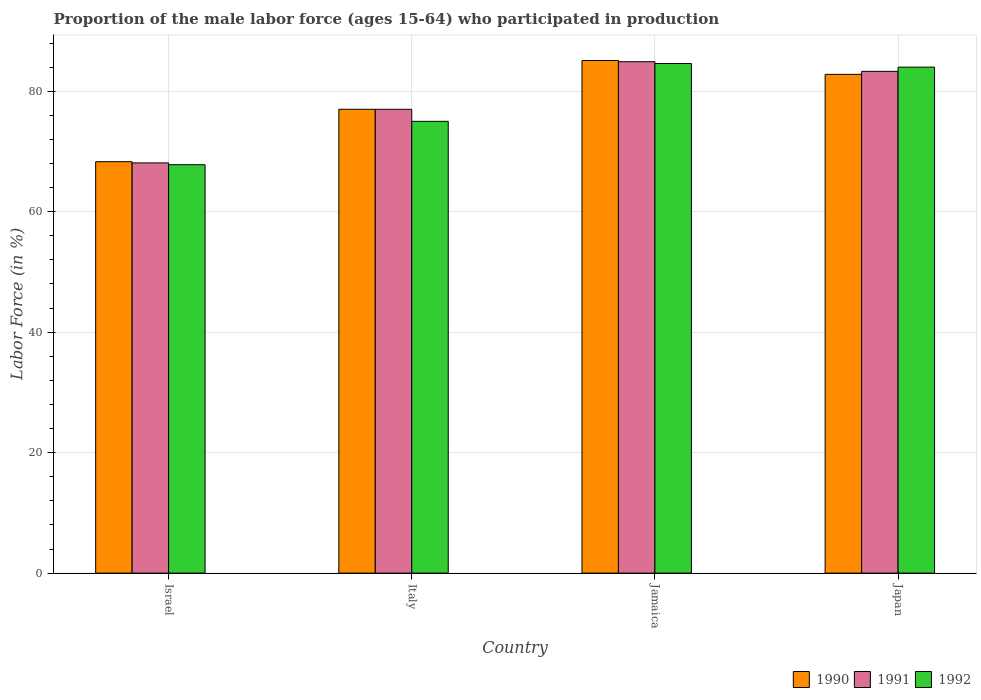How many groups of bars are there?
Provide a succinct answer. 4. Are the number of bars per tick equal to the number of legend labels?
Give a very brief answer. Yes. How many bars are there on the 4th tick from the left?
Keep it short and to the point. 3. How many bars are there on the 4th tick from the right?
Make the answer very short. 3. In how many cases, is the number of bars for a given country not equal to the number of legend labels?
Offer a very short reply. 0. Across all countries, what is the maximum proportion of the male labor force who participated in production in 1992?
Make the answer very short. 84.6. Across all countries, what is the minimum proportion of the male labor force who participated in production in 1992?
Provide a succinct answer. 67.8. In which country was the proportion of the male labor force who participated in production in 1991 maximum?
Provide a succinct answer. Jamaica. In which country was the proportion of the male labor force who participated in production in 1992 minimum?
Give a very brief answer. Israel. What is the total proportion of the male labor force who participated in production in 1991 in the graph?
Your answer should be very brief. 313.3. What is the difference between the proportion of the male labor force who participated in production in 1991 in Jamaica and that in Japan?
Your response must be concise. 1.6. What is the difference between the proportion of the male labor force who participated in production in 1992 in Jamaica and the proportion of the male labor force who participated in production in 1990 in Japan?
Offer a very short reply. 1.8. What is the average proportion of the male labor force who participated in production in 1990 per country?
Provide a short and direct response. 78.3. What is the ratio of the proportion of the male labor force who participated in production in 1991 in Italy to that in Jamaica?
Your answer should be very brief. 0.91. What is the difference between the highest and the second highest proportion of the male labor force who participated in production in 1991?
Give a very brief answer. -1.6. What is the difference between the highest and the lowest proportion of the male labor force who participated in production in 1991?
Offer a terse response. 16.8. Is the sum of the proportion of the male labor force who participated in production in 1990 in Israel and Italy greater than the maximum proportion of the male labor force who participated in production in 1991 across all countries?
Offer a terse response. Yes. What does the 3rd bar from the left in Japan represents?
Ensure brevity in your answer.  1992. What does the 1st bar from the right in Japan represents?
Ensure brevity in your answer.  1992. Is it the case that in every country, the sum of the proportion of the male labor force who participated in production in 1991 and proportion of the male labor force who participated in production in 1990 is greater than the proportion of the male labor force who participated in production in 1992?
Your answer should be compact. Yes. What is the title of the graph?
Offer a very short reply. Proportion of the male labor force (ages 15-64) who participated in production. What is the label or title of the X-axis?
Give a very brief answer. Country. What is the label or title of the Y-axis?
Offer a very short reply. Labor Force (in %). What is the Labor Force (in %) of 1990 in Israel?
Your response must be concise. 68.3. What is the Labor Force (in %) of 1991 in Israel?
Make the answer very short. 68.1. What is the Labor Force (in %) of 1992 in Israel?
Keep it short and to the point. 67.8. What is the Labor Force (in %) of 1990 in Italy?
Your response must be concise. 77. What is the Labor Force (in %) of 1991 in Italy?
Make the answer very short. 77. What is the Labor Force (in %) in 1990 in Jamaica?
Make the answer very short. 85.1. What is the Labor Force (in %) of 1991 in Jamaica?
Keep it short and to the point. 84.9. What is the Labor Force (in %) of 1992 in Jamaica?
Offer a terse response. 84.6. What is the Labor Force (in %) of 1990 in Japan?
Ensure brevity in your answer.  82.8. What is the Labor Force (in %) of 1991 in Japan?
Provide a succinct answer. 83.3. Across all countries, what is the maximum Labor Force (in %) of 1990?
Your response must be concise. 85.1. Across all countries, what is the maximum Labor Force (in %) of 1991?
Your answer should be compact. 84.9. Across all countries, what is the maximum Labor Force (in %) of 1992?
Provide a succinct answer. 84.6. Across all countries, what is the minimum Labor Force (in %) of 1990?
Ensure brevity in your answer.  68.3. Across all countries, what is the minimum Labor Force (in %) of 1991?
Offer a very short reply. 68.1. Across all countries, what is the minimum Labor Force (in %) in 1992?
Your answer should be compact. 67.8. What is the total Labor Force (in %) in 1990 in the graph?
Offer a terse response. 313.2. What is the total Labor Force (in %) in 1991 in the graph?
Keep it short and to the point. 313.3. What is the total Labor Force (in %) of 1992 in the graph?
Give a very brief answer. 311.4. What is the difference between the Labor Force (in %) in 1992 in Israel and that in Italy?
Keep it short and to the point. -7.2. What is the difference between the Labor Force (in %) in 1990 in Israel and that in Jamaica?
Your response must be concise. -16.8. What is the difference between the Labor Force (in %) of 1991 in Israel and that in Jamaica?
Provide a short and direct response. -16.8. What is the difference between the Labor Force (in %) of 1992 in Israel and that in Jamaica?
Make the answer very short. -16.8. What is the difference between the Labor Force (in %) of 1990 in Israel and that in Japan?
Keep it short and to the point. -14.5. What is the difference between the Labor Force (in %) in 1991 in Israel and that in Japan?
Give a very brief answer. -15.2. What is the difference between the Labor Force (in %) in 1992 in Israel and that in Japan?
Make the answer very short. -16.2. What is the difference between the Labor Force (in %) of 1991 in Italy and that in Jamaica?
Provide a short and direct response. -7.9. What is the difference between the Labor Force (in %) of 1992 in Italy and that in Jamaica?
Keep it short and to the point. -9.6. What is the difference between the Labor Force (in %) of 1990 in Italy and that in Japan?
Your answer should be very brief. -5.8. What is the difference between the Labor Force (in %) of 1991 in Jamaica and that in Japan?
Offer a very short reply. 1.6. What is the difference between the Labor Force (in %) of 1990 in Israel and the Labor Force (in %) of 1991 in Italy?
Your response must be concise. -8.7. What is the difference between the Labor Force (in %) in 1991 in Israel and the Labor Force (in %) in 1992 in Italy?
Your answer should be very brief. -6.9. What is the difference between the Labor Force (in %) of 1990 in Israel and the Labor Force (in %) of 1991 in Jamaica?
Make the answer very short. -16.6. What is the difference between the Labor Force (in %) in 1990 in Israel and the Labor Force (in %) in 1992 in Jamaica?
Offer a very short reply. -16.3. What is the difference between the Labor Force (in %) in 1991 in Israel and the Labor Force (in %) in 1992 in Jamaica?
Your response must be concise. -16.5. What is the difference between the Labor Force (in %) in 1990 in Israel and the Labor Force (in %) in 1992 in Japan?
Offer a very short reply. -15.7. What is the difference between the Labor Force (in %) in 1991 in Israel and the Labor Force (in %) in 1992 in Japan?
Make the answer very short. -15.9. What is the difference between the Labor Force (in %) of 1991 in Italy and the Labor Force (in %) of 1992 in Jamaica?
Provide a short and direct response. -7.6. What is the difference between the Labor Force (in %) in 1990 in Italy and the Labor Force (in %) in 1991 in Japan?
Your response must be concise. -6.3. What is the difference between the Labor Force (in %) in 1990 in Jamaica and the Labor Force (in %) in 1992 in Japan?
Your answer should be compact. 1.1. What is the average Labor Force (in %) in 1990 per country?
Make the answer very short. 78.3. What is the average Labor Force (in %) in 1991 per country?
Offer a terse response. 78.33. What is the average Labor Force (in %) of 1992 per country?
Keep it short and to the point. 77.85. What is the difference between the Labor Force (in %) in 1990 and Labor Force (in %) in 1991 in Israel?
Make the answer very short. 0.2. What is the difference between the Labor Force (in %) of 1990 and Labor Force (in %) of 1992 in Israel?
Offer a very short reply. 0.5. What is the difference between the Labor Force (in %) of 1990 and Labor Force (in %) of 1991 in Italy?
Provide a succinct answer. 0. What is the difference between the Labor Force (in %) in 1990 and Labor Force (in %) in 1992 in Italy?
Offer a very short reply. 2. What is the difference between the Labor Force (in %) in 1991 and Labor Force (in %) in 1992 in Italy?
Give a very brief answer. 2. What is the difference between the Labor Force (in %) in 1990 and Labor Force (in %) in 1991 in Jamaica?
Your answer should be very brief. 0.2. What is the difference between the Labor Force (in %) in 1991 and Labor Force (in %) in 1992 in Jamaica?
Your answer should be very brief. 0.3. What is the difference between the Labor Force (in %) of 1990 and Labor Force (in %) of 1991 in Japan?
Make the answer very short. -0.5. What is the difference between the Labor Force (in %) of 1990 and Labor Force (in %) of 1992 in Japan?
Your answer should be very brief. -1.2. What is the ratio of the Labor Force (in %) in 1990 in Israel to that in Italy?
Make the answer very short. 0.89. What is the ratio of the Labor Force (in %) of 1991 in Israel to that in Italy?
Your answer should be compact. 0.88. What is the ratio of the Labor Force (in %) of 1992 in Israel to that in Italy?
Offer a terse response. 0.9. What is the ratio of the Labor Force (in %) in 1990 in Israel to that in Jamaica?
Keep it short and to the point. 0.8. What is the ratio of the Labor Force (in %) in 1991 in Israel to that in Jamaica?
Provide a succinct answer. 0.8. What is the ratio of the Labor Force (in %) of 1992 in Israel to that in Jamaica?
Provide a succinct answer. 0.8. What is the ratio of the Labor Force (in %) in 1990 in Israel to that in Japan?
Give a very brief answer. 0.82. What is the ratio of the Labor Force (in %) of 1991 in Israel to that in Japan?
Your answer should be very brief. 0.82. What is the ratio of the Labor Force (in %) in 1992 in Israel to that in Japan?
Provide a short and direct response. 0.81. What is the ratio of the Labor Force (in %) of 1990 in Italy to that in Jamaica?
Make the answer very short. 0.9. What is the ratio of the Labor Force (in %) in 1991 in Italy to that in Jamaica?
Offer a terse response. 0.91. What is the ratio of the Labor Force (in %) in 1992 in Italy to that in Jamaica?
Make the answer very short. 0.89. What is the ratio of the Labor Force (in %) in 1990 in Italy to that in Japan?
Ensure brevity in your answer.  0.93. What is the ratio of the Labor Force (in %) in 1991 in Italy to that in Japan?
Give a very brief answer. 0.92. What is the ratio of the Labor Force (in %) of 1992 in Italy to that in Japan?
Offer a terse response. 0.89. What is the ratio of the Labor Force (in %) in 1990 in Jamaica to that in Japan?
Make the answer very short. 1.03. What is the ratio of the Labor Force (in %) of 1991 in Jamaica to that in Japan?
Make the answer very short. 1.02. What is the ratio of the Labor Force (in %) of 1992 in Jamaica to that in Japan?
Your answer should be compact. 1.01. What is the difference between the highest and the second highest Labor Force (in %) of 1991?
Provide a short and direct response. 1.6. What is the difference between the highest and the lowest Labor Force (in %) in 1991?
Your response must be concise. 16.8. 